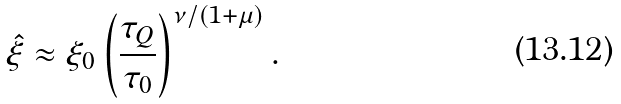Convert formula to latex. <formula><loc_0><loc_0><loc_500><loc_500>\hat { \xi } \approx \xi _ { 0 } \left ( \frac { \tau _ { Q } } { \tau _ { 0 } } \right ) ^ { \nu / ( 1 + \mu ) } .</formula> 